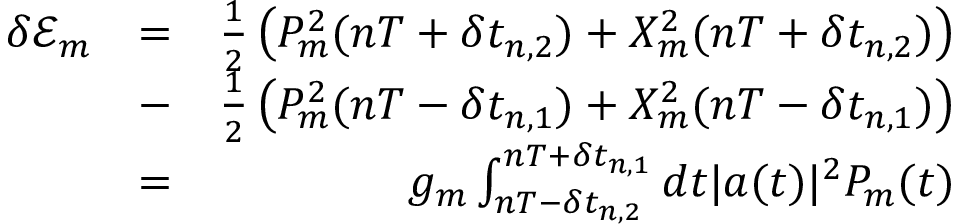Convert formula to latex. <formula><loc_0><loc_0><loc_500><loc_500>\begin{array} { r l r } { \delta \mathcal { E } _ { m } } & { = } & { \frac { 1 } { 2 } \left ( P _ { m } ^ { 2 } ( n T + \delta t _ { n , 2 } ) + X _ { m } ^ { 2 } ( n T + \delta t _ { n , 2 } ) \right ) } \\ & { - } & { \frac { 1 } { 2 } \left ( P _ { m } ^ { 2 } ( n T - \delta t _ { n , 1 } ) + X _ { m } ^ { 2 } ( n T - \delta t _ { n , 1 } ) \right ) } \\ & { = } & { g _ { m } \int _ { n T - \delta t _ { n , 2 } } ^ { n T + \delta t _ { n , 1 } } d t | a ( t ) | ^ { 2 } P _ { m } ( t ) } \end{array}</formula> 